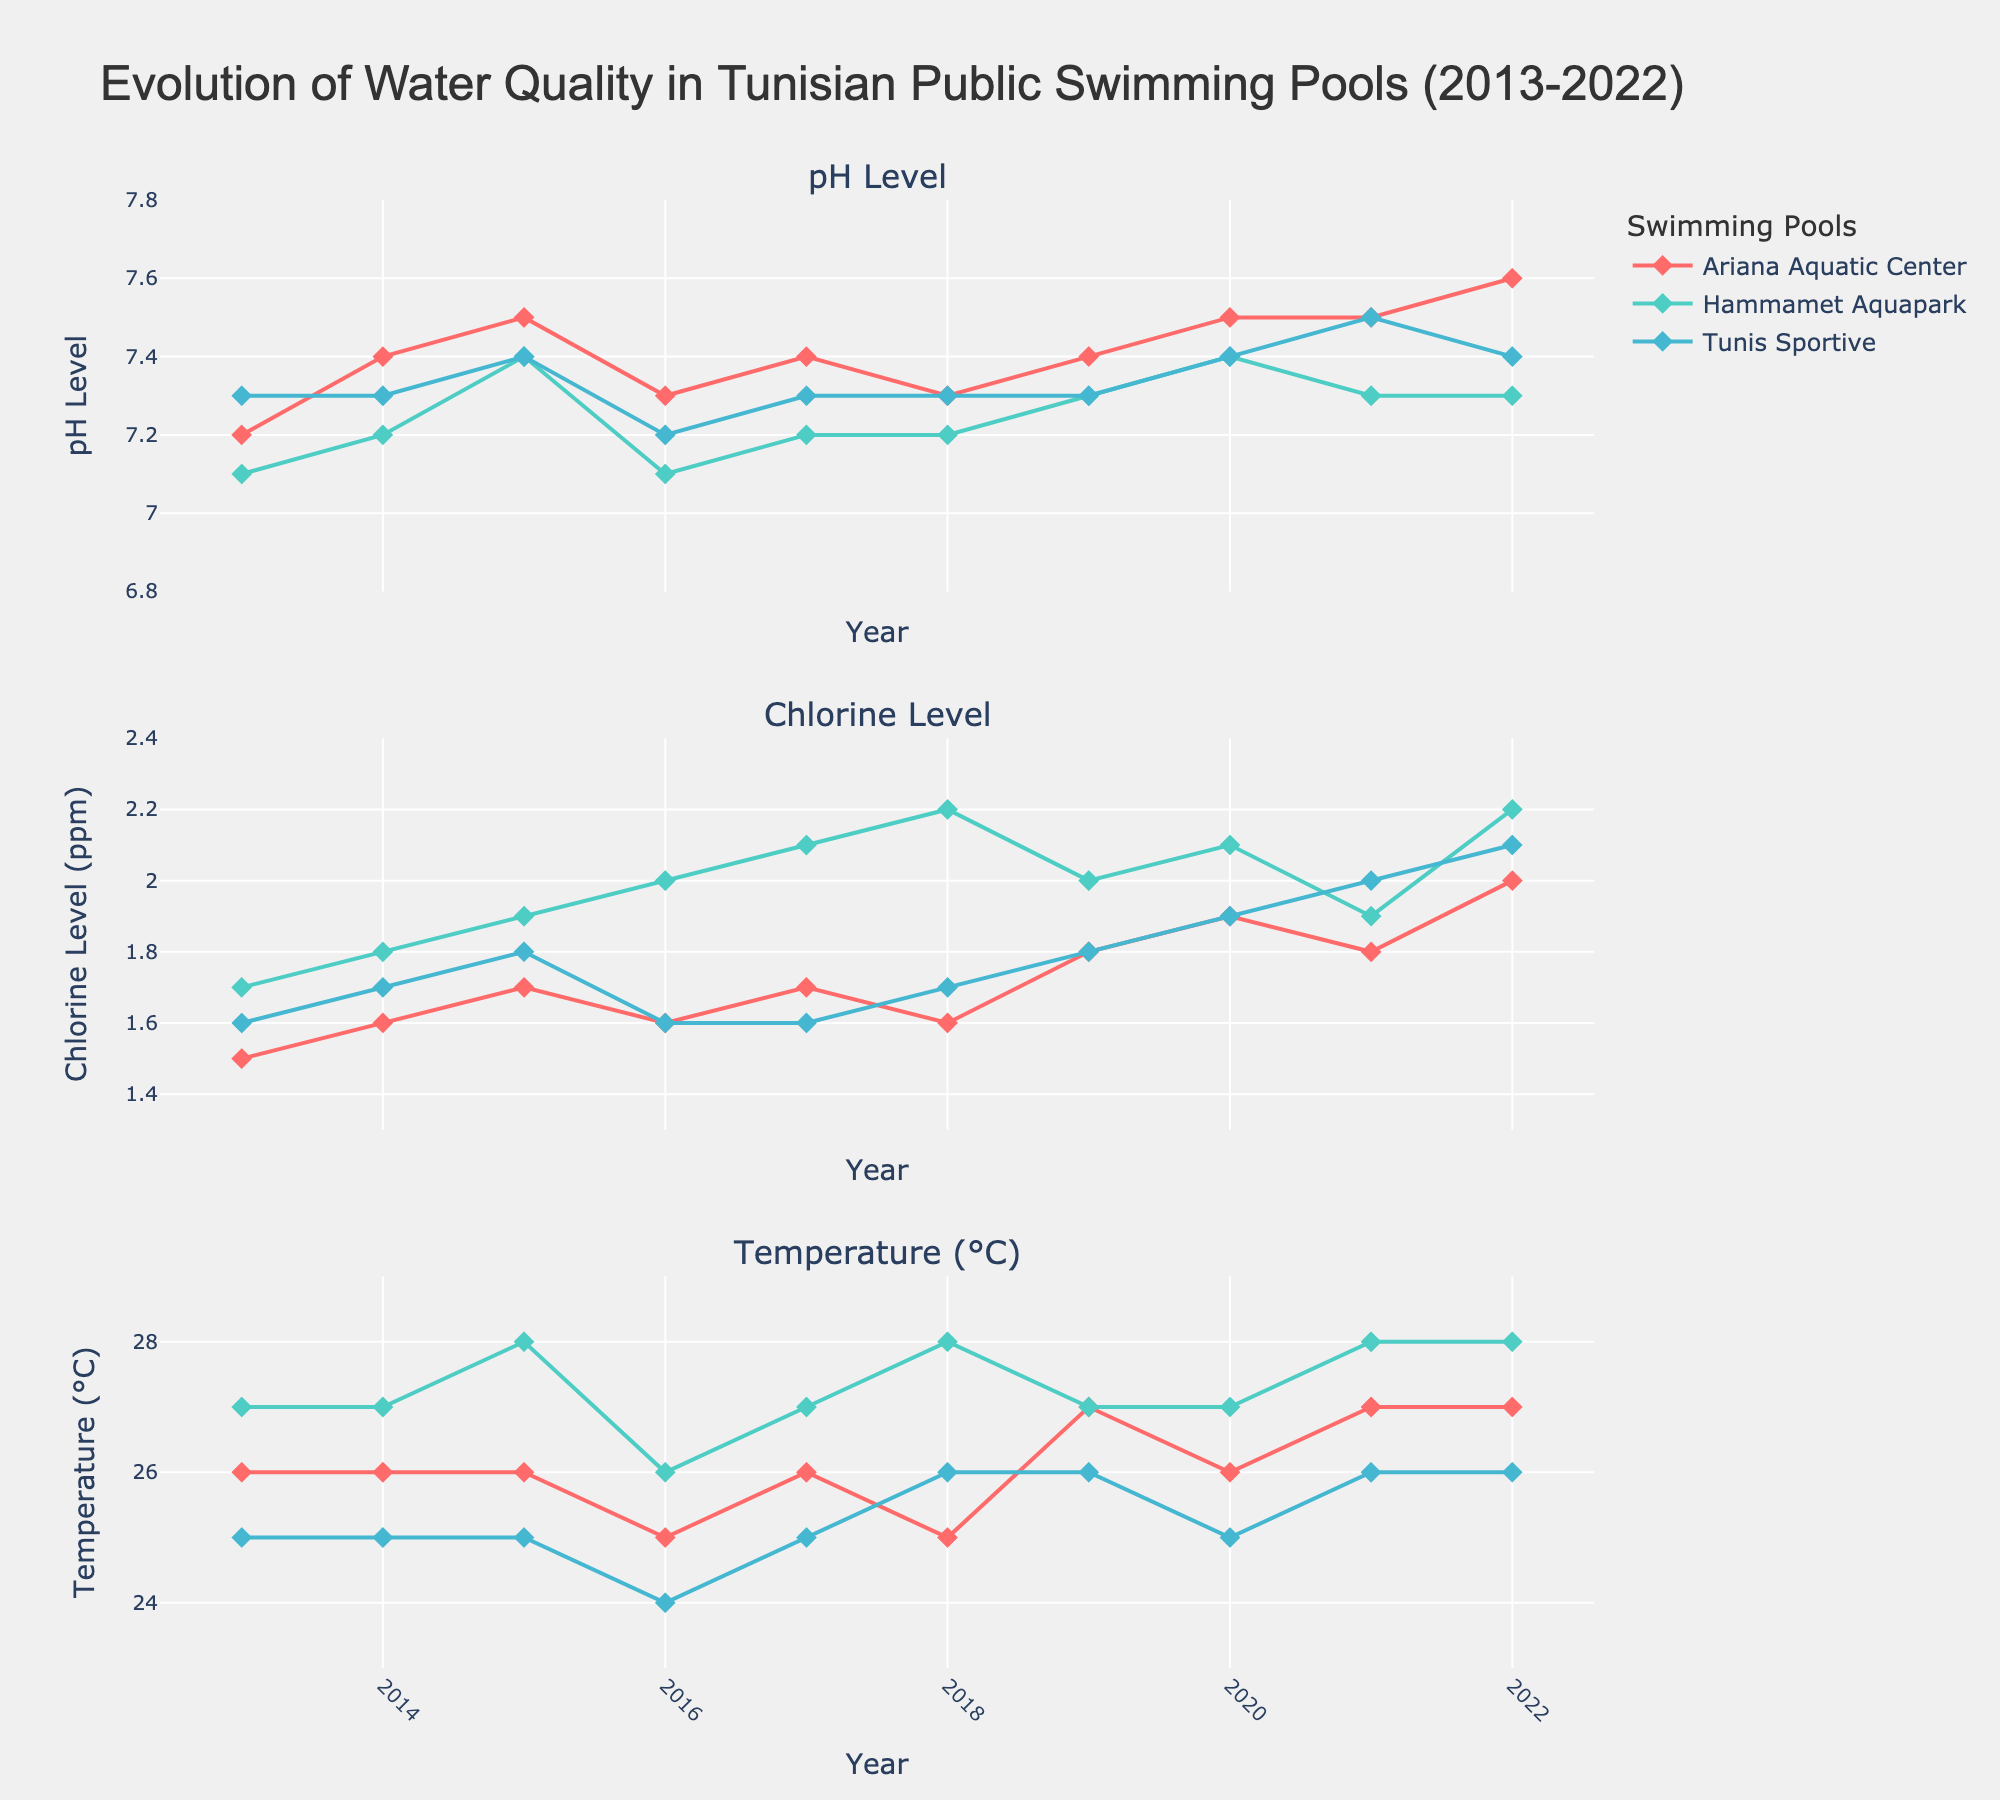What is the average pH level in the Hammamet Aquapark for the entire period? First, locate the Hammamet Aquapark data points in the pH Level subplot. Then, sum the pH levels for all years for Hammamet Aquapark (7.1, 7.2, 7.4, 7.1, 7.2, 7.2, 7.3, 7.4, 7.3, 7.3). Finally, divide the total by the number of data points (10). The calculations are as follows: (7.1 + 7.2 + 7.4 + 7.1 + 7.2 + 7.2 + 7.3 + 7.4 + 7.3 + 7.3) / 10 = 7.25.
Answer: 7.25 Which swimming pool has the highest chlorine level in 2022? Look at the Chlorine Level subplot for 2022. Check the chlorine levels for each swimming pool. Ariana Aquatic Center has 2.0, Hammamet Aquapark has 2.2, and Tunis Sportive has 2.1. The highest value among these is for Hammamet Aquapark.
Answer: Hammamet Aquapark How did the temperature change in the Ariana Aquatic Center from 2013 to 2022? Refer to the Temperature subplot and track the data points for the Ariana Aquatic Center from 2013 through 2022. Note the temperature values for these years (2013: 26, 2022: 27). The change is calculated as the final value (27) minus the initial value (26).
Answer: 1°C increase What was the difference in pH level between the Ariana Aquatic Center and Tunis Sportive in 2020? Locate the pH levels for both pools in 2020 on the pH Level subplot. Ariana Aquatic Center: 7.5, Tunis Sportive: 7.4. Calculate the difference: 7.5 - 7.4 = 0.1.
Answer: 0.1 Did the chlorine level in Tunis Sportive show a consistent trend over 10 years? Examine the Chlorine Level subplot for the data points corresponding to Tunis Sportive. The chlorine levels are: 1.6, 1.7, 1.8, 1.6, 1.6, 1.7, 1.8, 1.9, 1.9, 2.0, 2.1. These values show a general increasing trend.
Answer: Increasing trend What is the average temperature of Hammamet Aquapark for the years data is available? First, find the temperature values for Hammamet Aquapark across the years (27, 27, 28, 26, 27, 28, 27, 27, 28, 28). Sum these values: 273, then divide by the number of data points (10).
Answer: 27.3°C Which year does the Ariana Aquatic Center have the highest pH level? Look at the pH Level subplot for Ariana Aquatic Center and identify the data points. The highest pH level is 7.6, which occurs in 2022.
Answer: 2022 Between 2013 and 2022, which year did Hammamet Aquapark have the peak chlorine level? Refer to the Chlorine Level subplot and find the highest chlorine level for Hammamet Aquapark. The peak value is 2.2 in the year 2022.
Answer: 2022 How did the chlorine level in Hammamet Aquapark change from 2013 to 2022? Check the chlorine levels for Hammamet Aquapark in 2013 and 2022. The values are 1.7 in 2013 and 2.2 in 2022. The change is calculated as 2.2 - 1.7.
Answer: 0.5 increase 